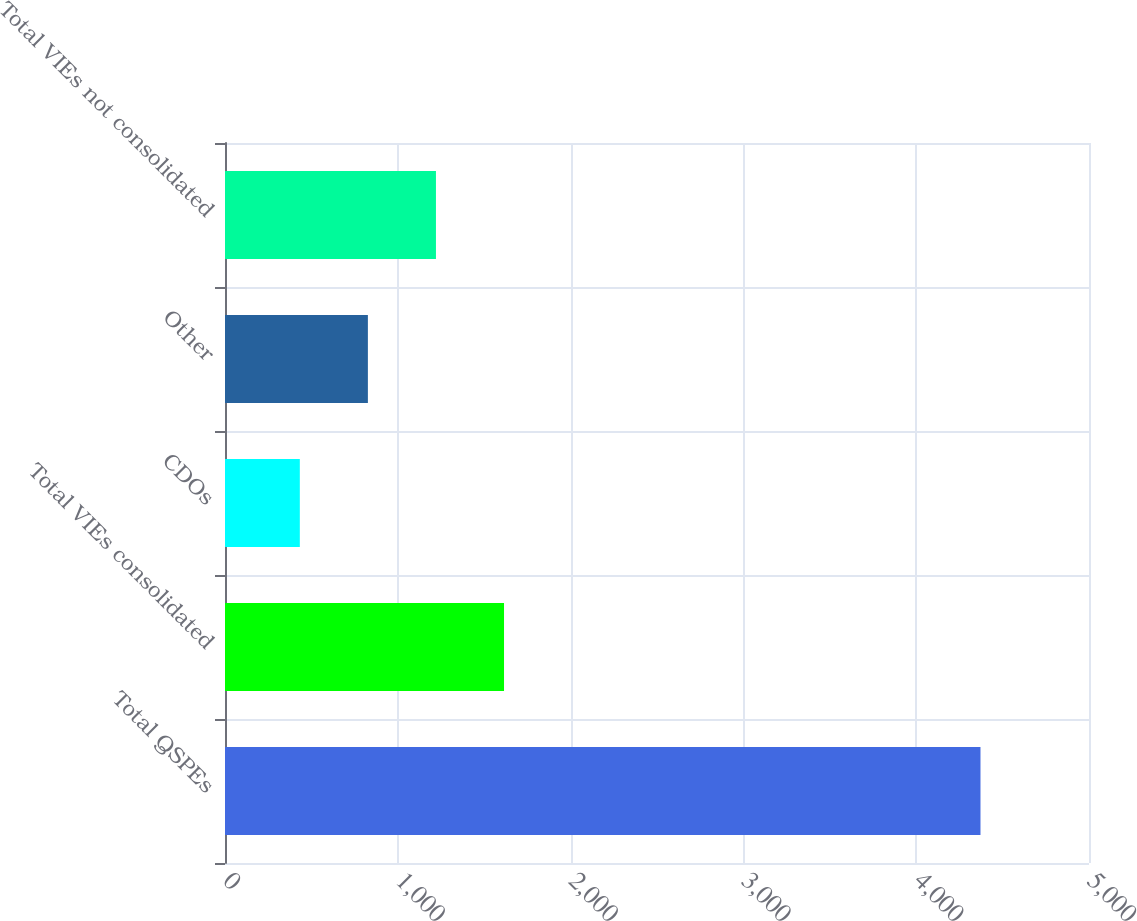Convert chart. <chart><loc_0><loc_0><loc_500><loc_500><bar_chart><fcel>Total QSPEs<fcel>Total VIEs consolidated<fcel>CDOs<fcel>Other<fcel>Total VIEs not consolidated<nl><fcel>4372<fcel>1614.7<fcel>433<fcel>826.9<fcel>1220.8<nl></chart> 